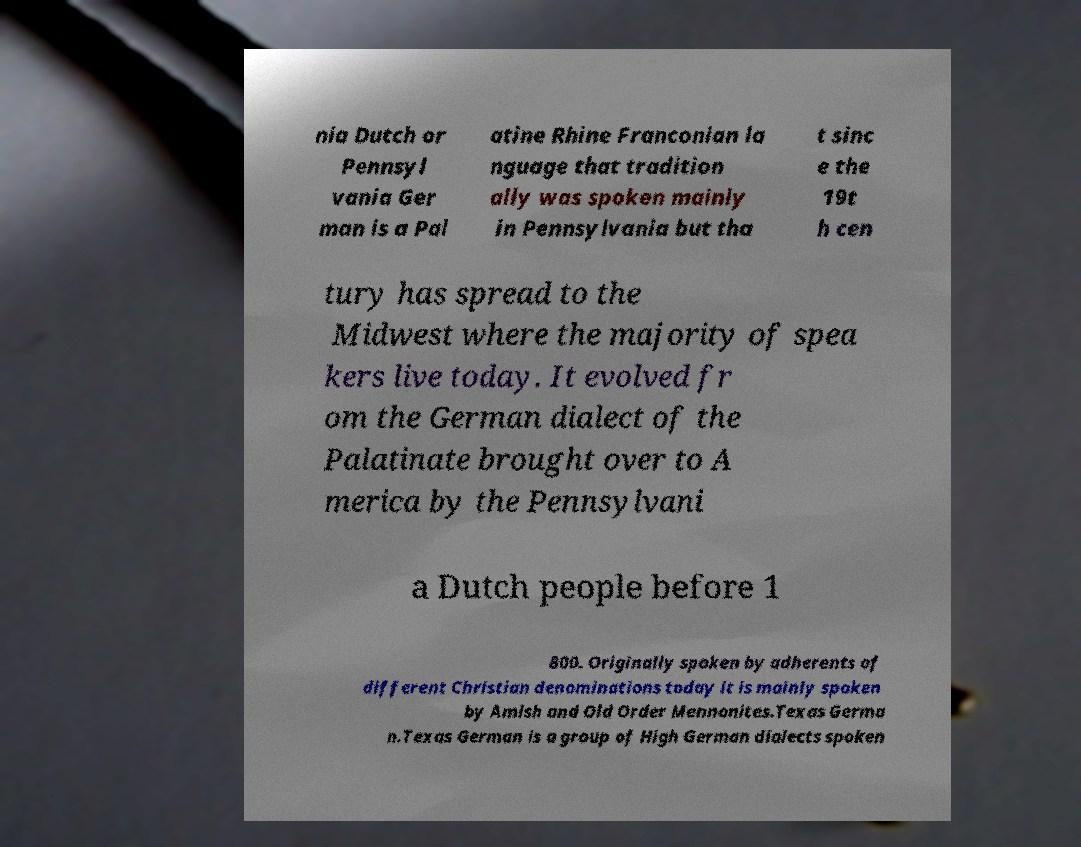Could you extract and type out the text from this image? nia Dutch or Pennsyl vania Ger man is a Pal atine Rhine Franconian la nguage that tradition ally was spoken mainly in Pennsylvania but tha t sinc e the 19t h cen tury has spread to the Midwest where the majority of spea kers live today. It evolved fr om the German dialect of the Palatinate brought over to A merica by the Pennsylvani a Dutch people before 1 800. Originally spoken by adherents of different Christian denominations today it is mainly spoken by Amish and Old Order Mennonites.Texas Germa n.Texas German is a group of High German dialects spoken 